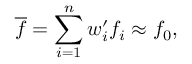<formula> <loc_0><loc_0><loc_500><loc_500>\overline { f } = \sum _ { i = 1 } ^ { n } w _ { i } ^ { \prime } f _ { i } \approx f _ { 0 } ,</formula> 